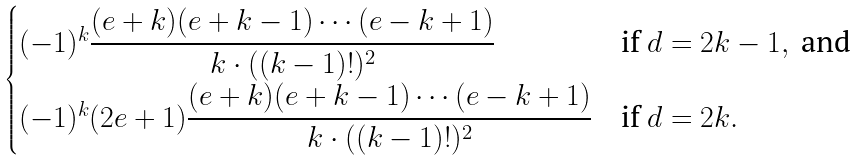<formula> <loc_0><loc_0><loc_500><loc_500>\begin{cases} ( - 1 ) ^ { k } \cfrac { ( e + k ) ( e + k - 1 ) \cdots ( e - k + 1 ) } { k \cdot ( ( k - 1 ) ! ) ^ { 2 } } & \text {if } d = 2 k - 1 , \text { and} \\ ( - 1 ) ^ { k } ( 2 e + 1 ) \cfrac { ( e + k ) ( e + k - 1 ) \cdots ( e - k + 1 ) } { k \cdot ( ( k - 1 ) ! ) ^ { 2 } } & \text {if } d = 2 k . \end{cases}</formula> 